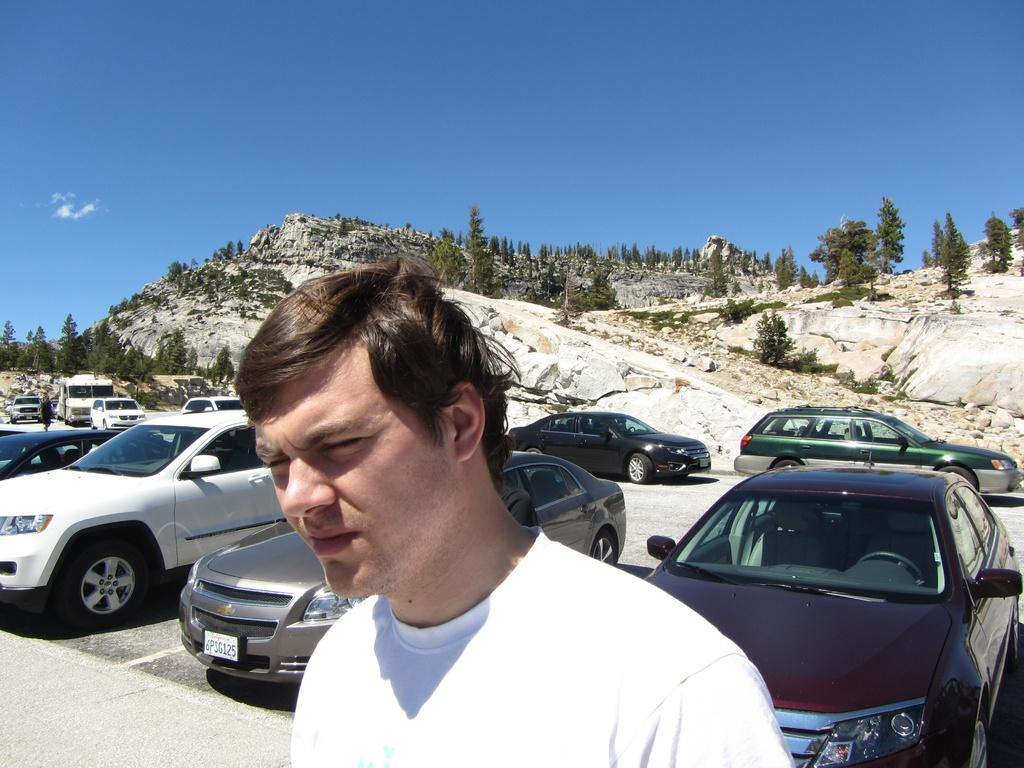Who or what is at the bottom of the image? There is a person at the bottom of the image. What is located in the middle of the image? There are vehicles in the middle of the image. What is the terrain feature at the top of the image? There is a hill at the top of the image. What can be seen in the sky in the image? The sky is visible at the top of the image. What type of vegetation is on the hill in the image? There are trees on the hill in the image. What type of lock can be seen on the person's toe in the image? There is no lock or toe visible in the image; it features a person, vehicles, a hill, trees, and the sky. 